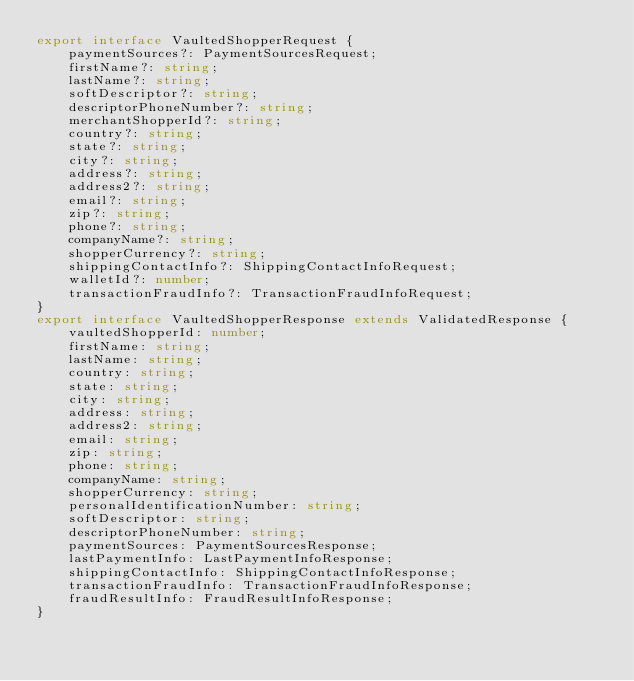<code> <loc_0><loc_0><loc_500><loc_500><_TypeScript_>export interface VaultedShopperRequest {
    paymentSources?: PaymentSourcesRequest;
    firstName?: string;
    lastName?: string;
    softDescriptor?: string;
    descriptorPhoneNumber?: string;
    merchantShopperId?: string;
    country?: string;
    state?: string;
    city?: string;
    address?: string;
    address2?: string;
    email?: string;
    zip?: string;
    phone?: string;
    companyName?: string;
    shopperCurrency?: string;
    shippingContactInfo?: ShippingContactInfoRequest;
    walletId?: number;
    transactionFraudInfo?: TransactionFraudInfoRequest;
}
export interface VaultedShopperResponse extends ValidatedResponse {
    vaultedShopperId: number;
    firstName: string;
    lastName: string;
    country: string;
    state: string;
    city: string;
    address: string;
    address2: string;
    email: string;
    zip: string;
    phone: string;
    companyName: string;
    shopperCurrency: string;
    personalIdentificationNumber: string;
    softDescriptor: string;
    descriptorPhoneNumber: string;
    paymentSources: PaymentSourcesResponse;
    lastPaymentInfo: LastPaymentInfoResponse;
    shippingContactInfo: ShippingContactInfoResponse;
    transactionFraudInfo: TransactionFraudInfoResponse;
    fraudResultInfo: FraudResultInfoResponse;
}
</code> 